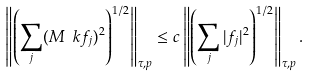<formula> <loc_0><loc_0><loc_500><loc_500>\left \| \left ( \sum _ { j } ( M _ { \ } k f _ { j } ) ^ { 2 } \right ) ^ { 1 / 2 } \right \| _ { \tau , p } \leq c \left \| \left ( \sum _ { j } | f _ { j } | ^ { 2 } \right ) ^ { 1 / 2 } \right \| _ { \tau , p } .</formula> 